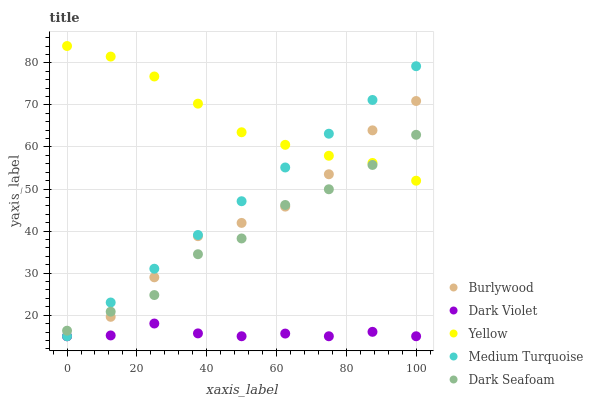Does Dark Violet have the minimum area under the curve?
Answer yes or no. Yes. Does Yellow have the maximum area under the curve?
Answer yes or no. Yes. Does Medium Turquoise have the minimum area under the curve?
Answer yes or no. No. Does Medium Turquoise have the maximum area under the curve?
Answer yes or no. No. Is Medium Turquoise the smoothest?
Answer yes or no. Yes. Is Dark Seafoam the roughest?
Answer yes or no. Yes. Is Dark Seafoam the smoothest?
Answer yes or no. No. Is Medium Turquoise the roughest?
Answer yes or no. No. Does Burlywood have the lowest value?
Answer yes or no. Yes. Does Dark Seafoam have the lowest value?
Answer yes or no. No. Does Yellow have the highest value?
Answer yes or no. Yes. Does Medium Turquoise have the highest value?
Answer yes or no. No. Is Dark Violet less than Dark Seafoam?
Answer yes or no. Yes. Is Dark Seafoam greater than Dark Violet?
Answer yes or no. Yes. Does Medium Turquoise intersect Burlywood?
Answer yes or no. Yes. Is Medium Turquoise less than Burlywood?
Answer yes or no. No. Is Medium Turquoise greater than Burlywood?
Answer yes or no. No. Does Dark Violet intersect Dark Seafoam?
Answer yes or no. No. 